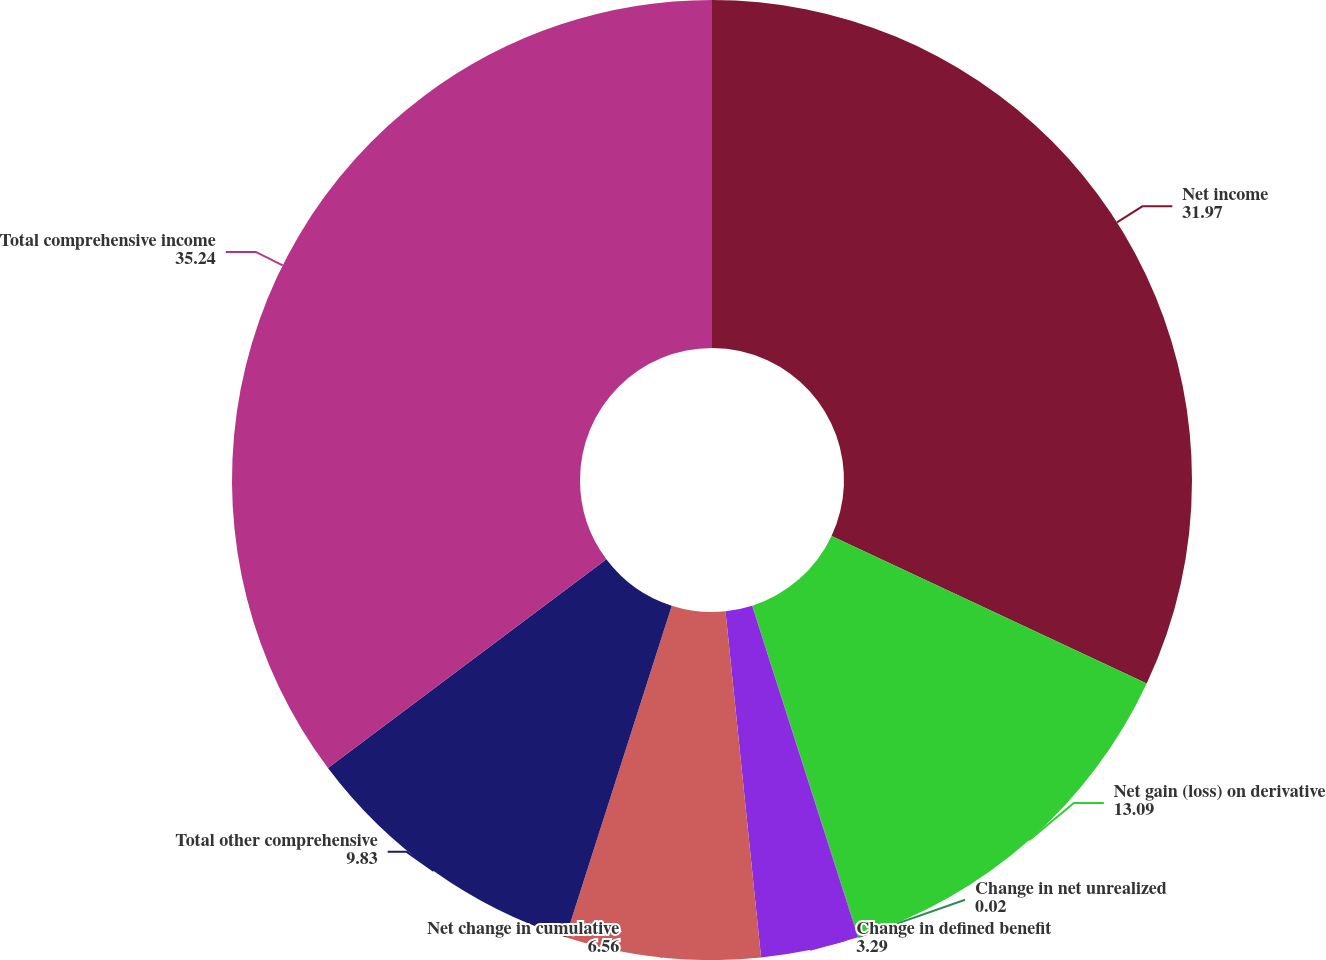Convert chart to OTSL. <chart><loc_0><loc_0><loc_500><loc_500><pie_chart><fcel>Net income<fcel>Net gain (loss) on derivative<fcel>Change in net unrealized<fcel>Change in defined benefit<fcel>Net change in cumulative<fcel>Total other comprehensive<fcel>Total comprehensive income<nl><fcel>31.97%<fcel>13.09%<fcel>0.02%<fcel>3.29%<fcel>6.56%<fcel>9.83%<fcel>35.24%<nl></chart> 